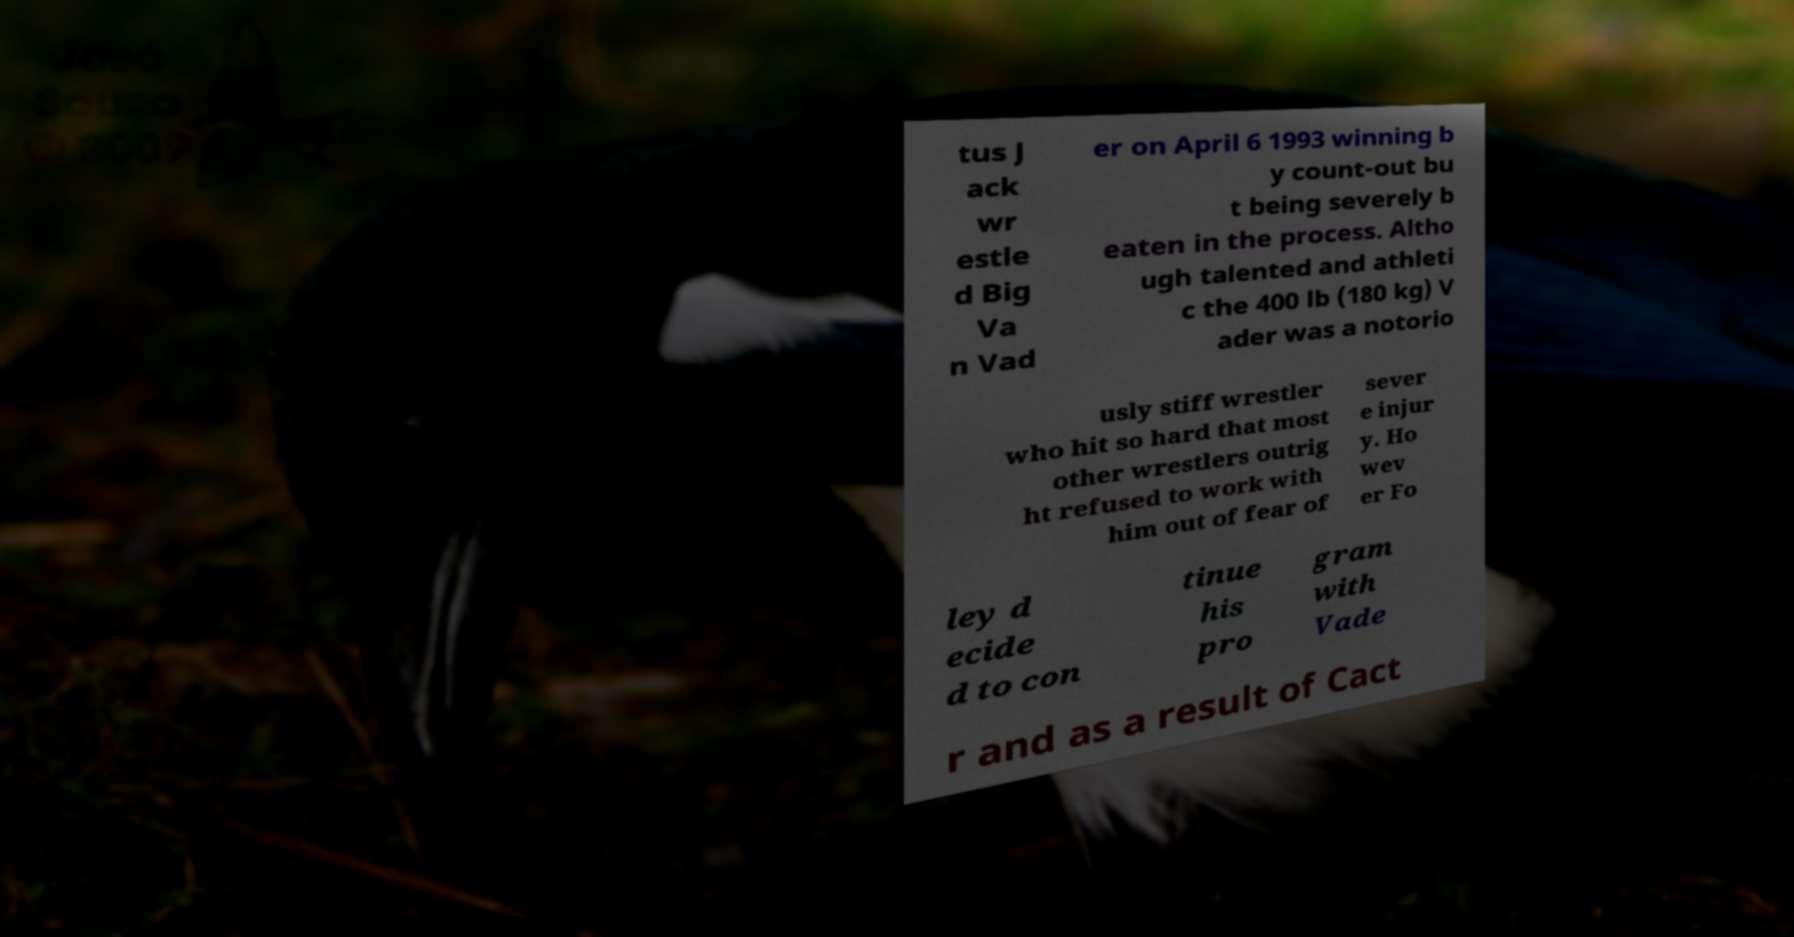What messages or text are displayed in this image? I need them in a readable, typed format. tus J ack wr estle d Big Va n Vad er on April 6 1993 winning b y count-out bu t being severely b eaten in the process. Altho ugh talented and athleti c the 400 lb (180 kg) V ader was a notorio usly stiff wrestler who hit so hard that most other wrestlers outrig ht refused to work with him out of fear of sever e injur y. Ho wev er Fo ley d ecide d to con tinue his pro gram with Vade r and as a result of Cact 